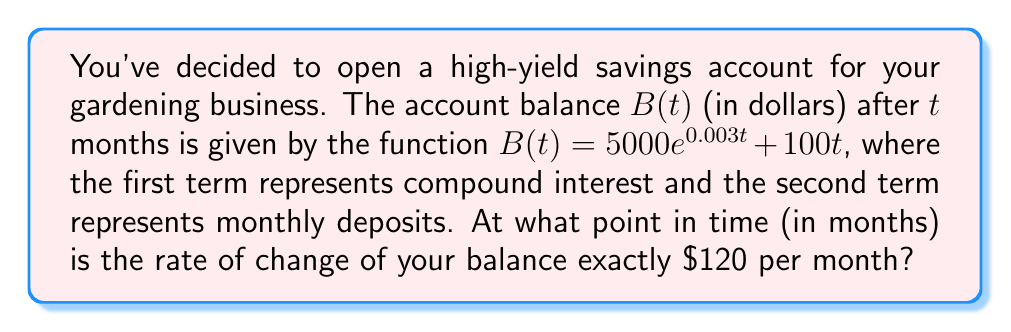What is the answer to this math problem? To solve this problem, we'll follow these steps:

1) First, we need to find the rate of change of the balance function. This is given by the derivative of $B(t)$ with respect to $t$.

   $$\frac{dB}{dt} = \frac{d}{dt}(5000e^{0.003t} + 100t)$$
   
   $$\frac{dB}{dt} = 5000 \cdot 0.003e^{0.003t} + 100$$
   
   $$\frac{dB}{dt} = 15e^{0.003t} + 100$$

2) We want to find when this rate of change equals 120, so we set up the equation:

   $$15e^{0.003t} + 100 = 120$$

3) Subtract 100 from both sides:

   $$15e^{0.003t} = 20$$

4) Divide both sides by 15:

   $$e^{0.003t} = \frac{4}{3}$$

5) Take the natural logarithm of both sides:

   $$0.003t = \ln(\frac{4}{3})$$

6) Divide both sides by 0.003:

   $$t = \frac{\ln(\frac{4}{3})}{0.003}$$

7) Calculate the result:

   $$t \approx 92.103$$ months
Answer: $92.103$ months 